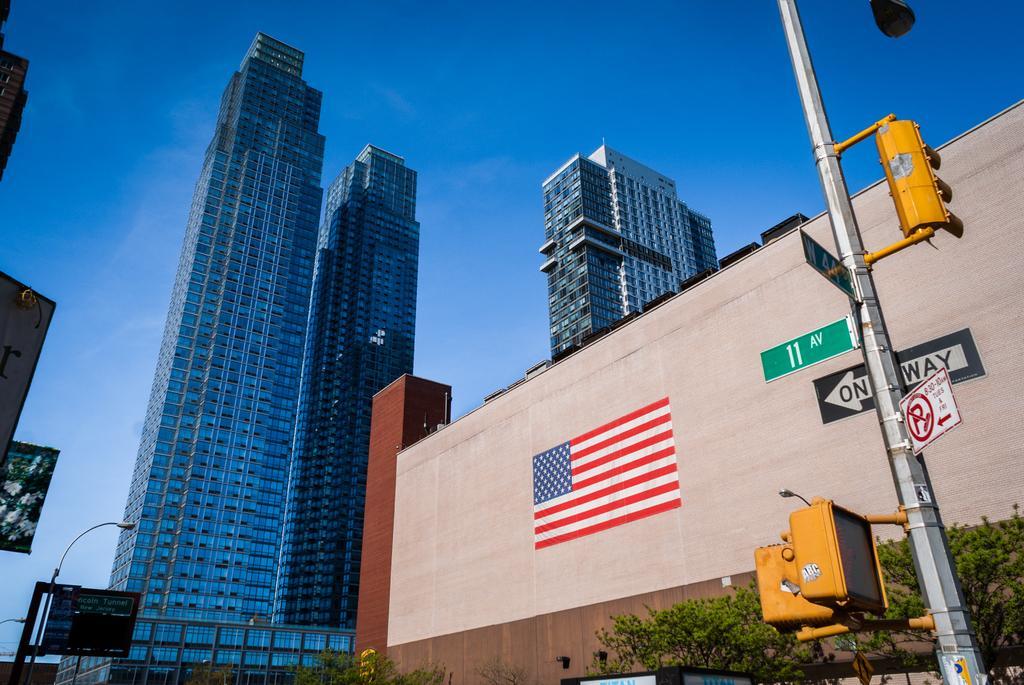Could you give a brief overview of what you see in this image? In this picture we can see a few signboards and traffic signals on the pole on the right side. There are a few trees, street lights and buildings in the background. Sky is blue in color. 